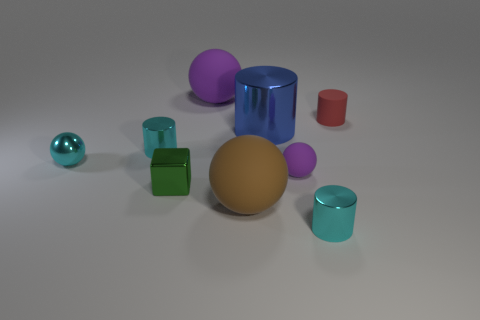Subtract all spheres. How many objects are left? 5 Subtract all blue cylinders. How many cylinders are left? 3 Subtract all small metallic balls. How many balls are left? 3 Subtract 1 blocks. How many blocks are left? 0 Subtract all purple cubes. Subtract all gray balls. How many cubes are left? 1 Subtract all purple balls. How many gray cylinders are left? 0 Subtract all large brown spheres. Subtract all spheres. How many objects are left? 4 Add 2 blue things. How many blue things are left? 3 Add 1 brown objects. How many brown objects exist? 2 Subtract 1 green cubes. How many objects are left? 8 